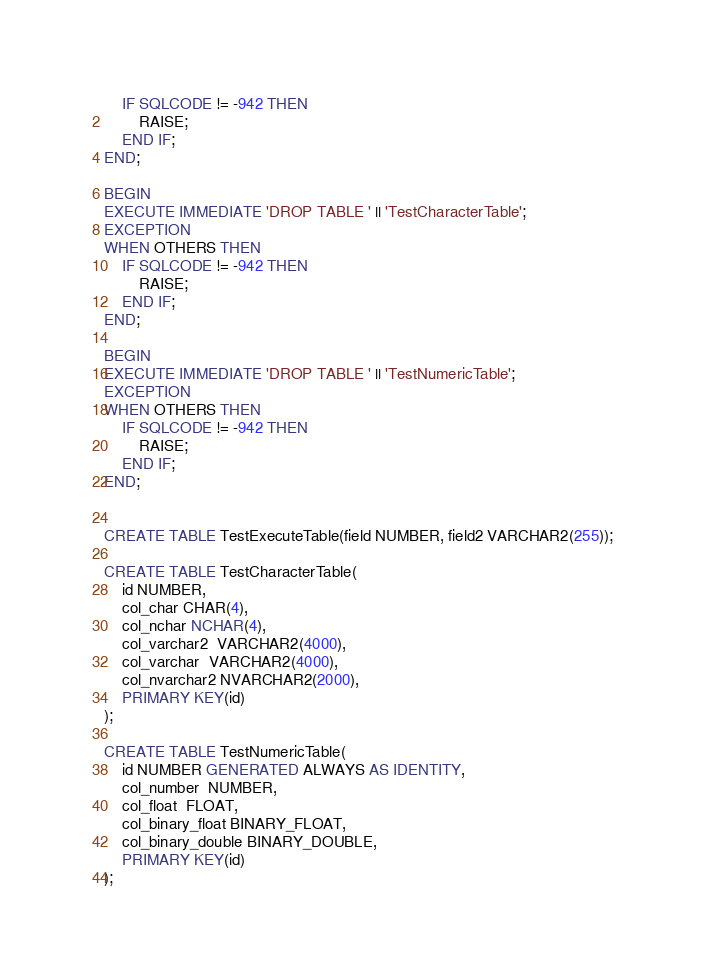<code> <loc_0><loc_0><loc_500><loc_500><_SQL_>    IF SQLCODE != -942 THEN
        RAISE;
    END IF;
END;

BEGIN
EXECUTE IMMEDIATE 'DROP TABLE ' || 'TestCharacterTable';
EXCEPTION
WHEN OTHERS THEN
    IF SQLCODE != -942 THEN
        RAISE;
    END IF;
END;

BEGIN
EXECUTE IMMEDIATE 'DROP TABLE ' || 'TestNumericTable';
EXCEPTION
WHEN OTHERS THEN
    IF SQLCODE != -942 THEN
        RAISE;
    END IF;
END;


CREATE TABLE TestExecuteTable(field NUMBER, field2 VARCHAR2(255));
    
CREATE TABLE TestCharacterTable(
    id NUMBER,
    col_char CHAR(4),
    col_nchar NCHAR(4),
    col_varchar2  VARCHAR2(4000),
    col_varchar  VARCHAR2(4000),
    col_nvarchar2 NVARCHAR2(2000),
    PRIMARY KEY(id)
);

CREATE TABLE TestNumericTable(
    id NUMBER GENERATED ALWAYS AS IDENTITY,
    col_number  NUMBER,
    col_float  FLOAT,
    col_binary_float BINARY_FLOAT, 
    col_binary_double BINARY_DOUBLE,
    PRIMARY KEY(id)
);
</code> 